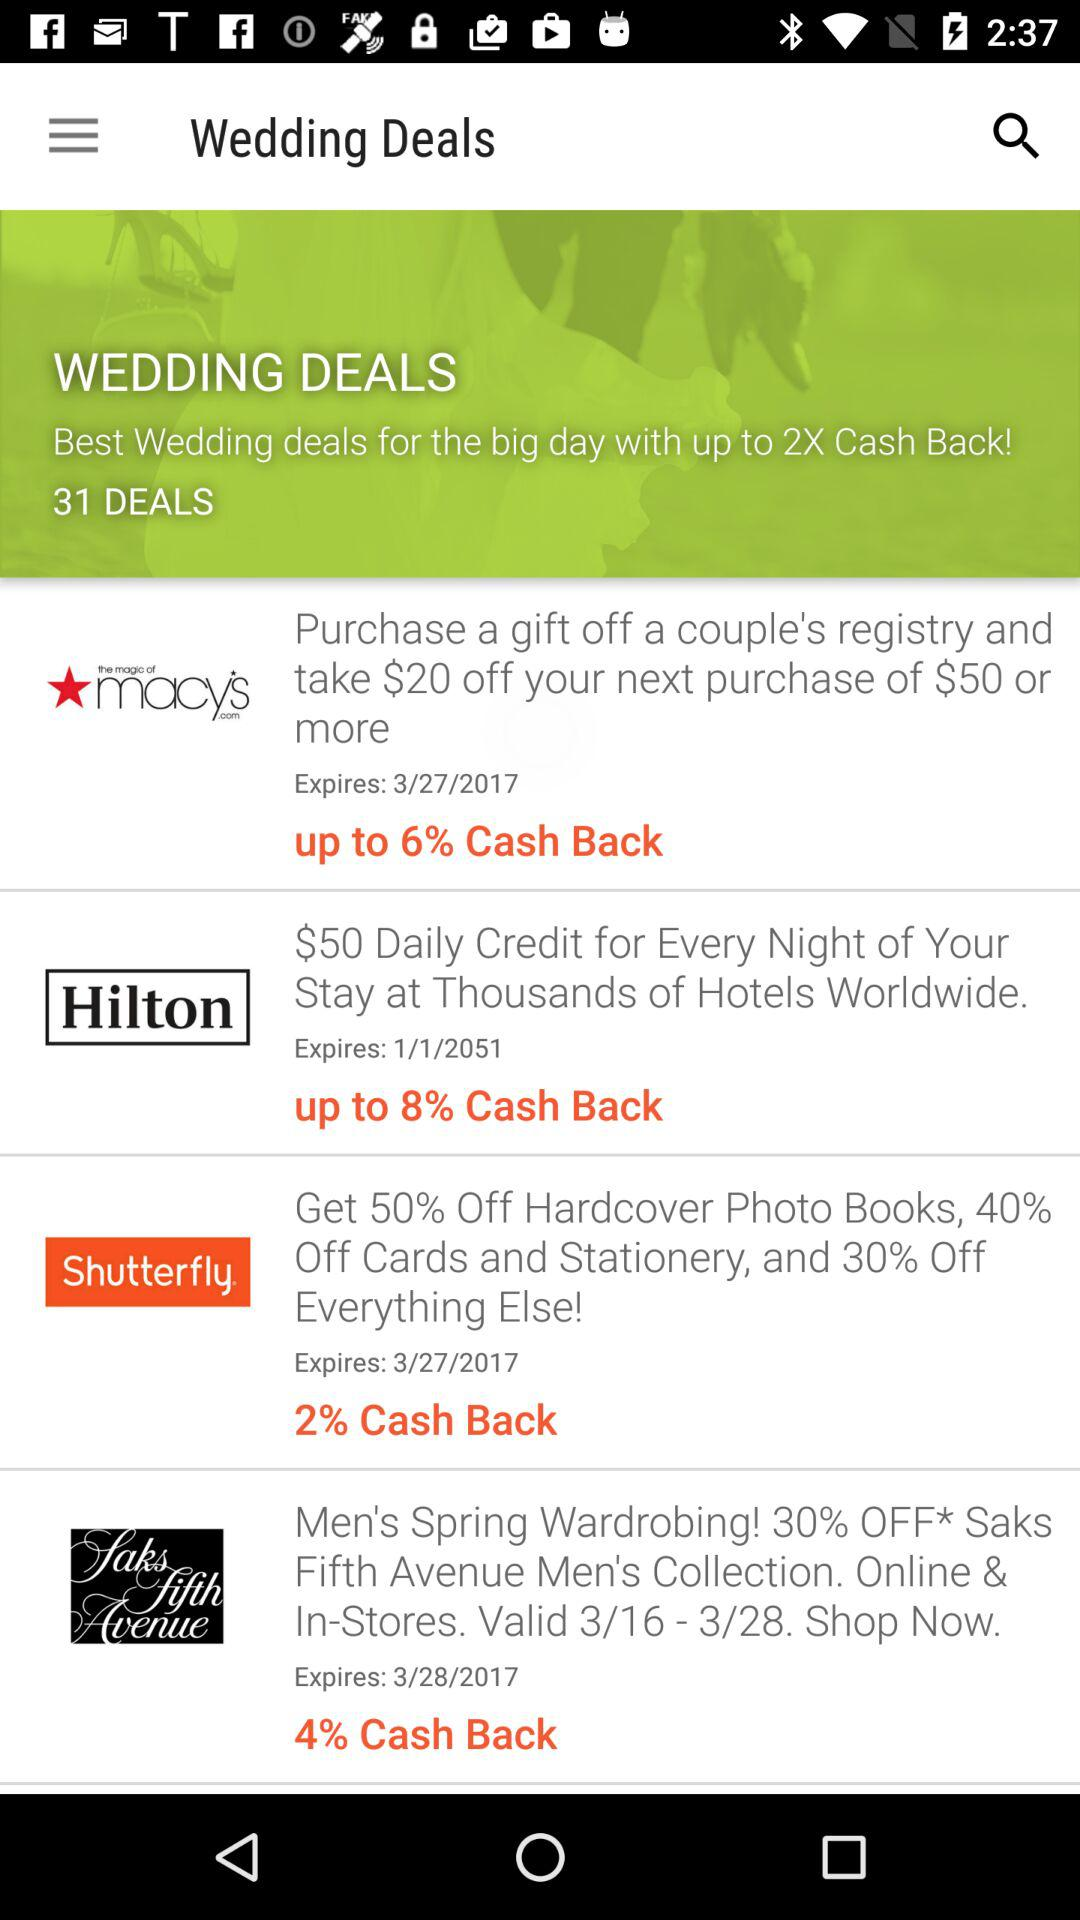How much cashback is there on "Saks Fifth Avenue"? The cashback is 4%. 